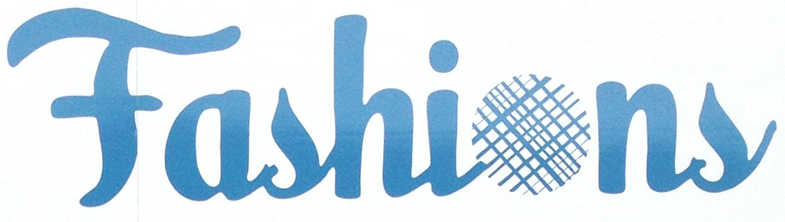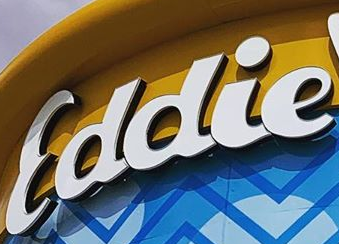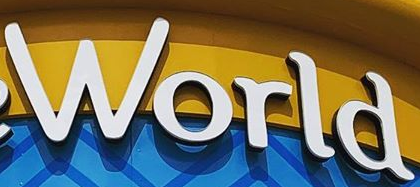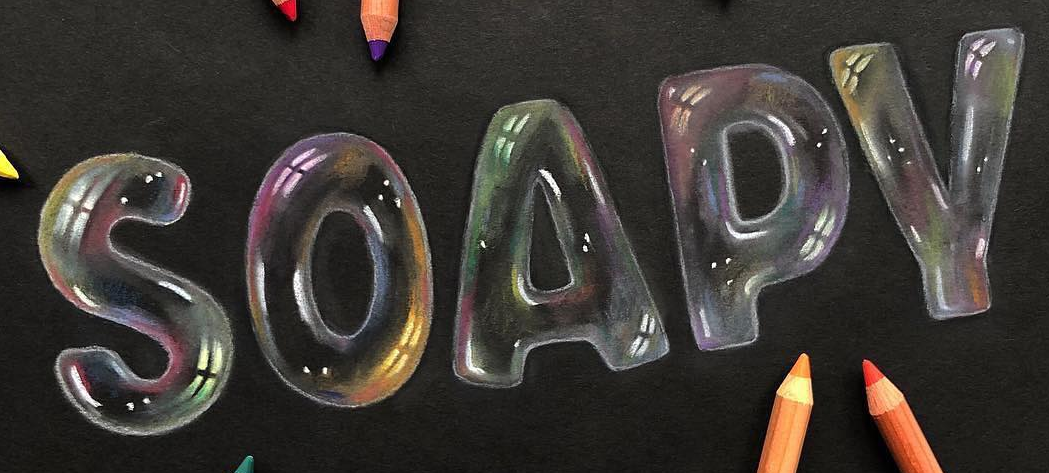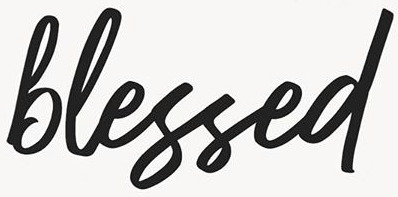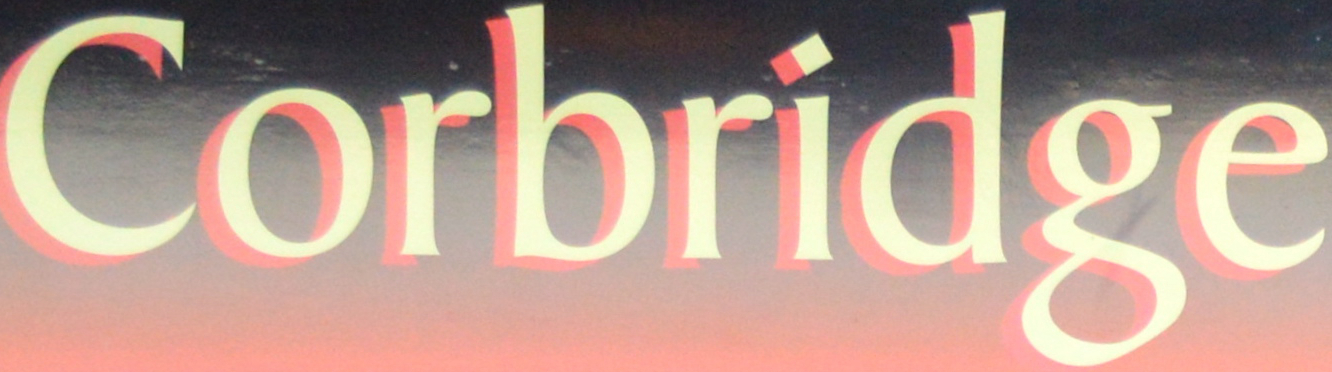What words can you see in these images in sequence, separated by a semicolon? Fashions; Eddie; World; SOAPY; blessed; Corbridge 